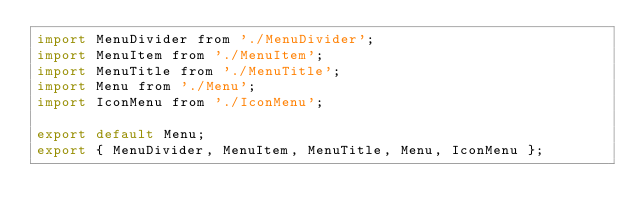Convert code to text. <code><loc_0><loc_0><loc_500><loc_500><_JavaScript_>import MenuDivider from './MenuDivider';
import MenuItem from './MenuItem';
import MenuTitle from './MenuTitle';
import Menu from './Menu';
import IconMenu from './IconMenu';

export default Menu;
export { MenuDivider, MenuItem, MenuTitle, Menu, IconMenu };
</code> 